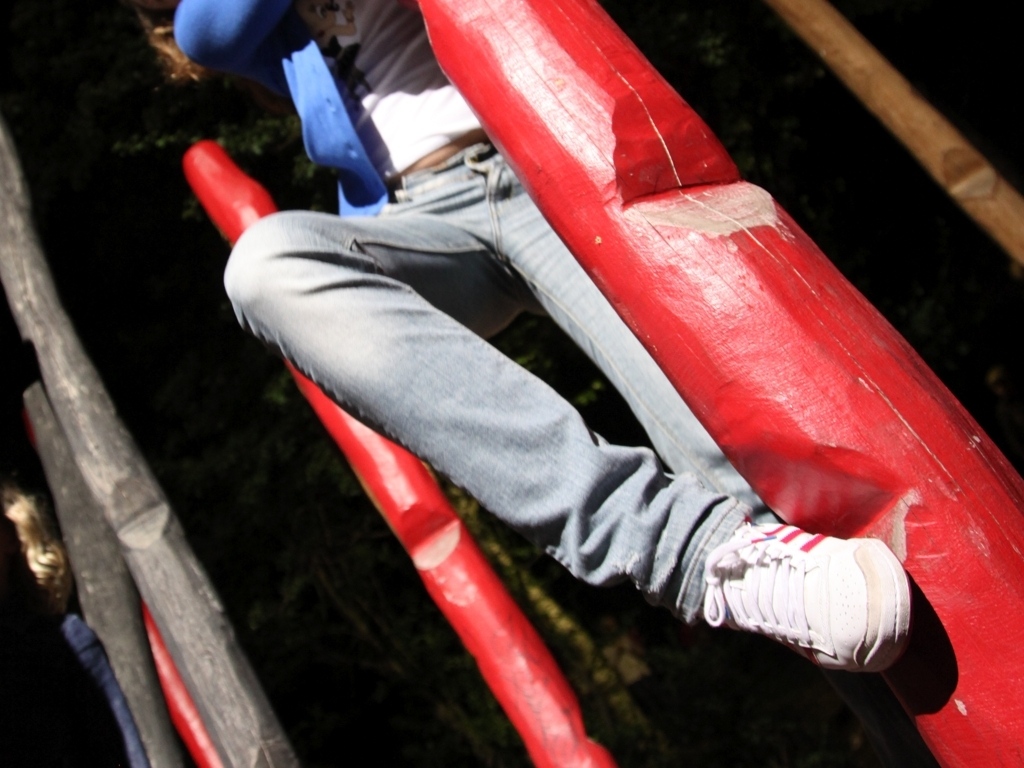Can you describe the clothing of the person in the image? The person is wearing casual outdoor apparel, featuring a pair of blue jeans and white sneakers. The attire suggests a setting suited for physical activity or play. 